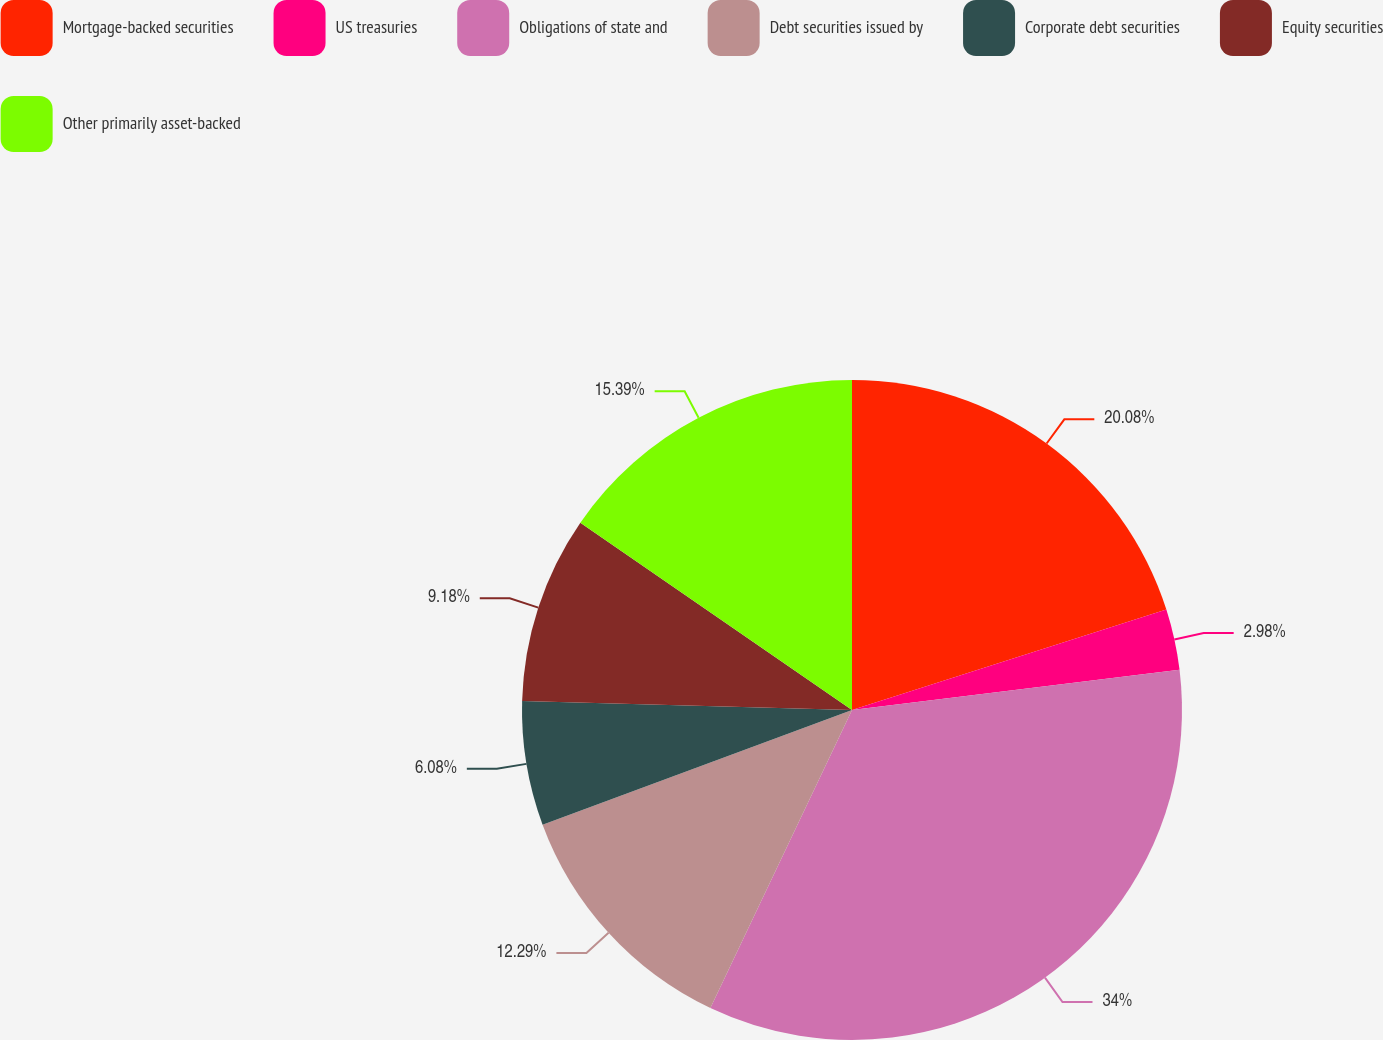Convert chart to OTSL. <chart><loc_0><loc_0><loc_500><loc_500><pie_chart><fcel>Mortgage-backed securities<fcel>US treasuries<fcel>Obligations of state and<fcel>Debt securities issued by<fcel>Corporate debt securities<fcel>Equity securities<fcel>Other primarily asset-backed<nl><fcel>20.08%<fcel>2.98%<fcel>34.0%<fcel>12.29%<fcel>6.08%<fcel>9.18%<fcel>15.39%<nl></chart> 